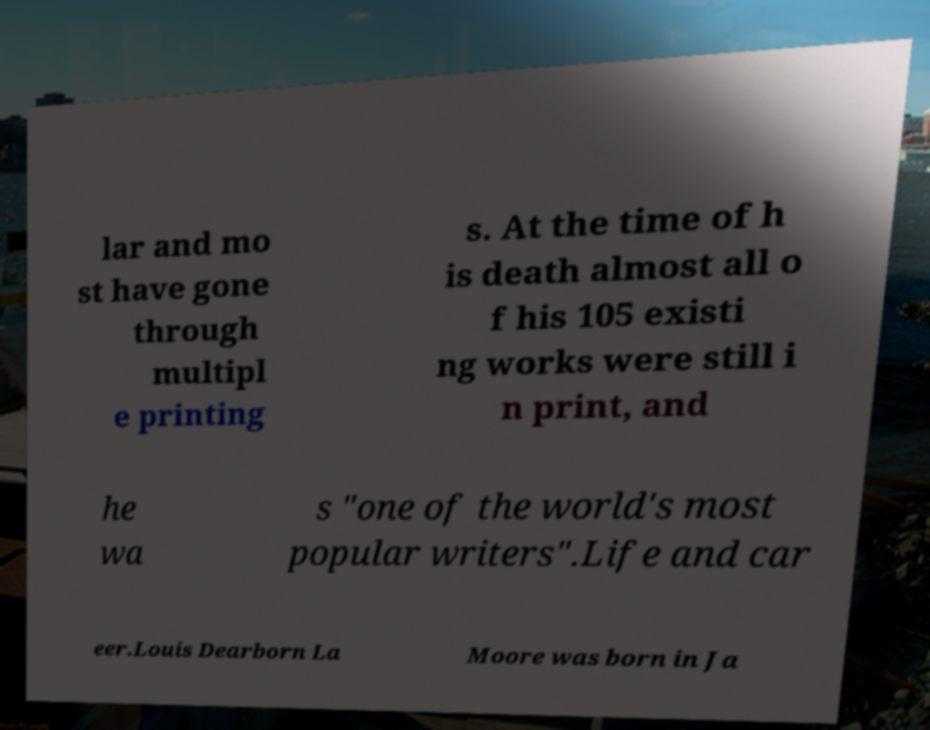For documentation purposes, I need the text within this image transcribed. Could you provide that? lar and mo st have gone through multipl e printing s. At the time of h is death almost all o f his 105 existi ng works were still i n print, and he wa s "one of the world's most popular writers".Life and car eer.Louis Dearborn La Moore was born in Ja 